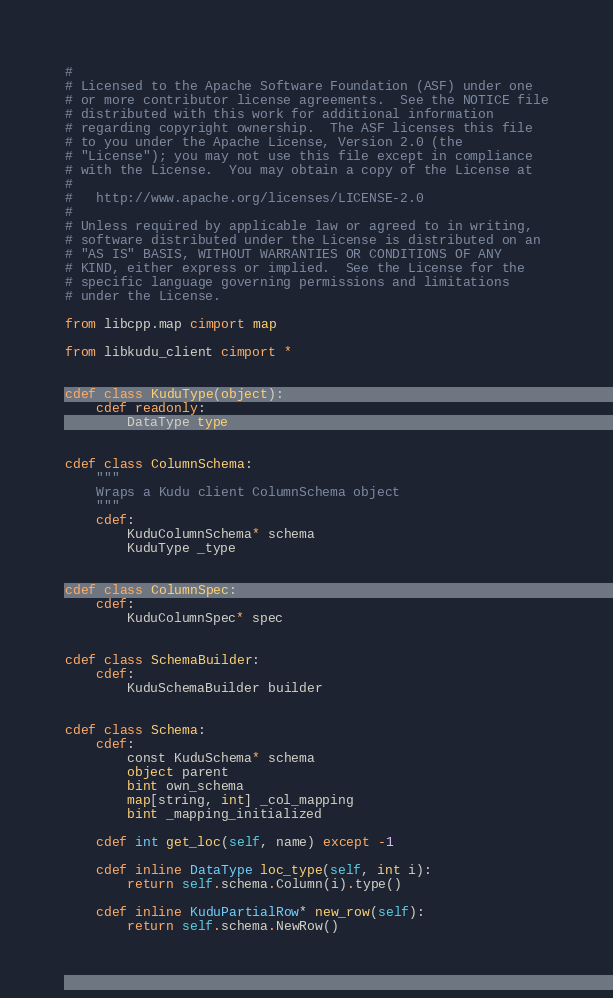Convert code to text. <code><loc_0><loc_0><loc_500><loc_500><_Cython_>#
# Licensed to the Apache Software Foundation (ASF) under one
# or more contributor license agreements.  See the NOTICE file
# distributed with this work for additional information
# regarding copyright ownership.  The ASF licenses this file
# to you under the Apache License, Version 2.0 (the
# "License"); you may not use this file except in compliance
# with the License.  You may obtain a copy of the License at
#
#   http://www.apache.org/licenses/LICENSE-2.0
#
# Unless required by applicable law or agreed to in writing,
# software distributed under the License is distributed on an
# "AS IS" BASIS, WITHOUT WARRANTIES OR CONDITIONS OF ANY
# KIND, either express or implied.  See the License for the
# specific language governing permissions and limitations
# under the License.

from libcpp.map cimport map

from libkudu_client cimport *


cdef class KuduType(object):
    cdef readonly:
        DataType type


cdef class ColumnSchema:
    """
    Wraps a Kudu client ColumnSchema object
    """
    cdef:
        KuduColumnSchema* schema
        KuduType _type


cdef class ColumnSpec:
    cdef:
        KuduColumnSpec* spec


cdef class SchemaBuilder:
    cdef:
        KuduSchemaBuilder builder


cdef class Schema:
    cdef:
        const KuduSchema* schema
        object parent
        bint own_schema
        map[string, int] _col_mapping
        bint _mapping_initialized

    cdef int get_loc(self, name) except -1

    cdef inline DataType loc_type(self, int i):
        return self.schema.Column(i).type()

    cdef inline KuduPartialRow* new_row(self):
        return self.schema.NewRow()
</code> 